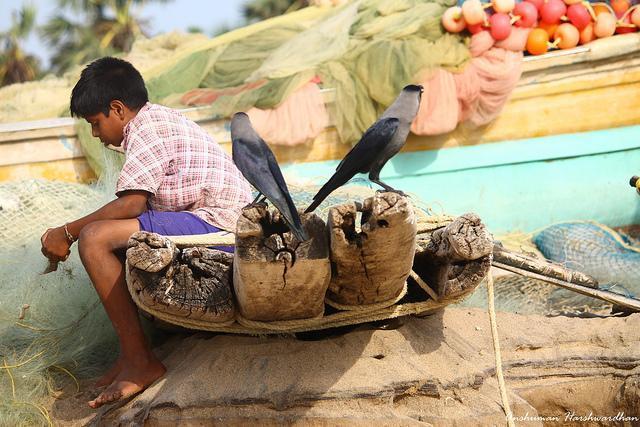How many birds can be seen?
Give a very brief answer. 2. How many people are between the two orange buses in the image?
Give a very brief answer. 0. 